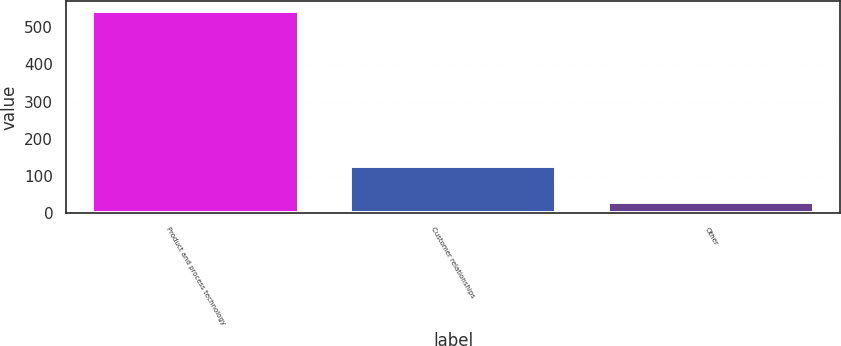<chart> <loc_0><loc_0><loc_500><loc_500><bar_chart><fcel>Product and process technology<fcel>Customer relationships<fcel>Other<nl><fcel>544<fcel>127<fcel>29<nl></chart> 